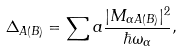<formula> <loc_0><loc_0><loc_500><loc_500>\Delta _ { A ( B ) } = \sum a \frac { | M _ { \alpha A ( B ) } | ^ { 2 } } { \hbar { \omega } _ { \alpha } } ,</formula> 